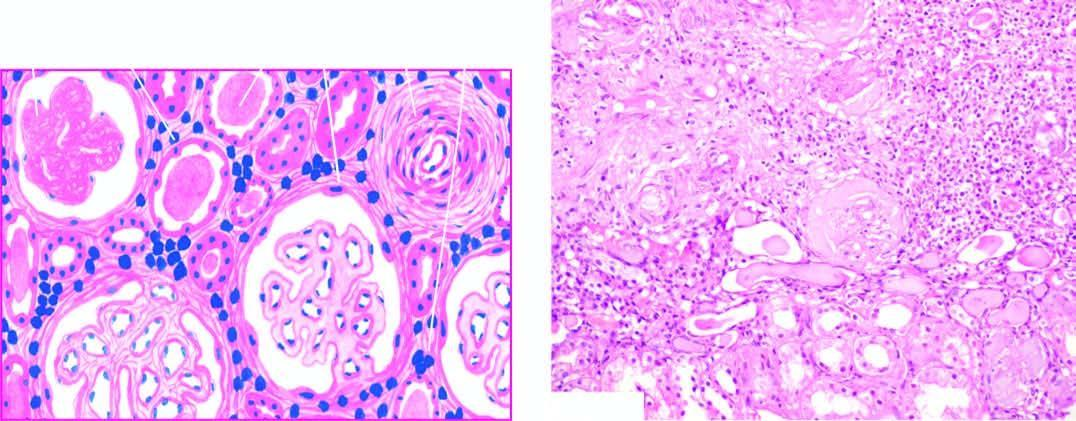what shows atrophy of some tubules and dilatation of others which contain colloid casts thyroidisation?
Answer the question using a single word or phrase. Scarred area 